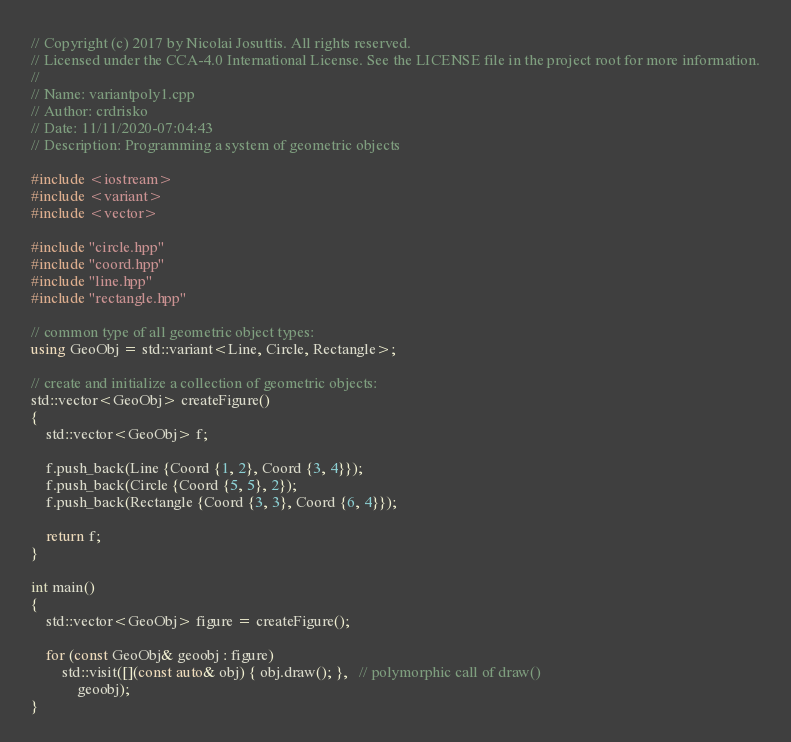<code> <loc_0><loc_0><loc_500><loc_500><_C++_>// Copyright (c) 2017 by Nicolai Josuttis. All rights reserved.
// Licensed under the CCA-4.0 International License. See the LICENSE file in the project root for more information.
//
// Name: variantpoly1.cpp
// Author: crdrisko
// Date: 11/11/2020-07:04:43
// Description: Programming a system of geometric objects

#include <iostream>
#include <variant>
#include <vector>

#include "circle.hpp"
#include "coord.hpp"
#include "line.hpp"
#include "rectangle.hpp"

// common type of all geometric object types:
using GeoObj = std::variant<Line, Circle, Rectangle>;

// create and initialize a collection of geometric objects:
std::vector<GeoObj> createFigure()
{
    std::vector<GeoObj> f;

    f.push_back(Line {Coord {1, 2}, Coord {3, 4}});
    f.push_back(Circle {Coord {5, 5}, 2});
    f.push_back(Rectangle {Coord {3, 3}, Coord {6, 4}});

    return f;
}

int main()
{
    std::vector<GeoObj> figure = createFigure();

    for (const GeoObj& geoobj : figure)
        std::visit([](const auto& obj) { obj.draw(); },   // polymorphic call of draw()
            geoobj);
}
</code> 